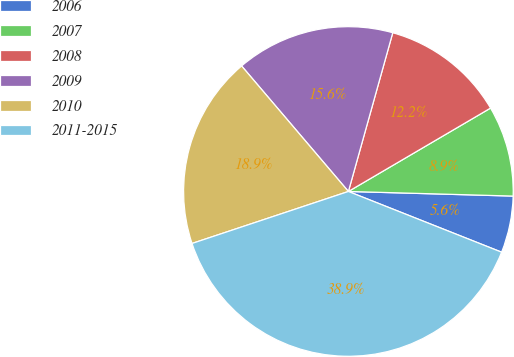Convert chart. <chart><loc_0><loc_0><loc_500><loc_500><pie_chart><fcel>2006<fcel>2007<fcel>2008<fcel>2009<fcel>2010<fcel>2011-2015<nl><fcel>5.56%<fcel>8.89%<fcel>12.22%<fcel>15.56%<fcel>18.89%<fcel>38.89%<nl></chart> 